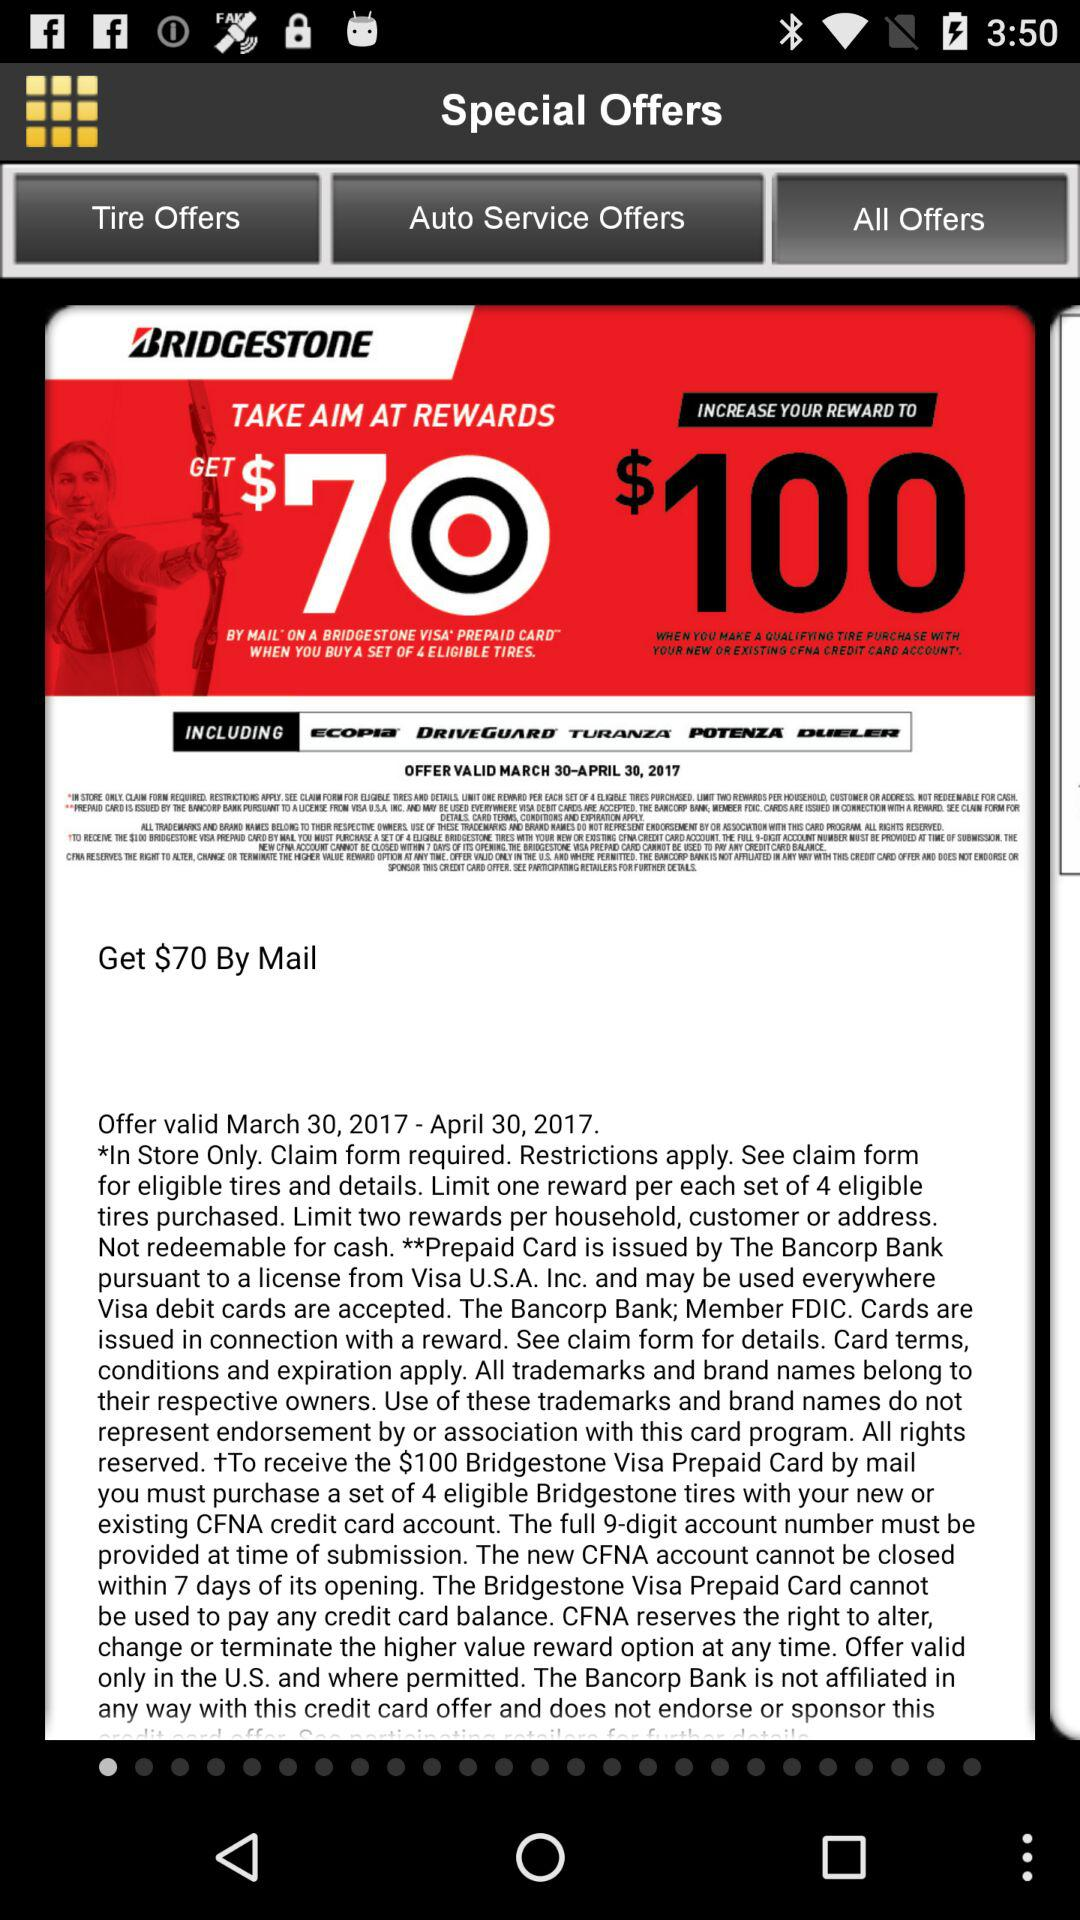How many rewards are offered by Bridgestone?
Answer the question using a single word or phrase. 2 